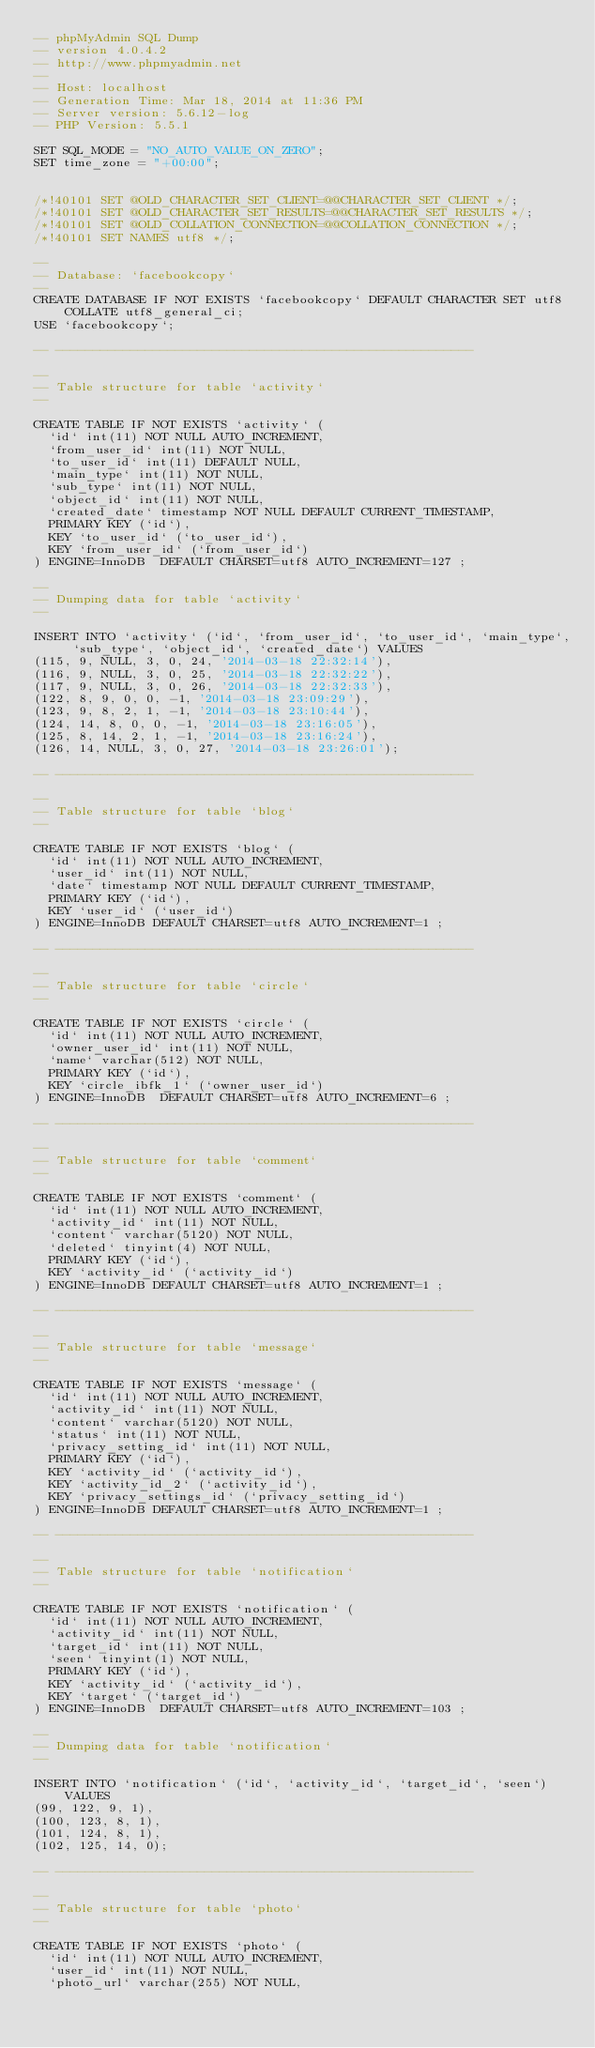Convert code to text. <code><loc_0><loc_0><loc_500><loc_500><_SQL_>-- phpMyAdmin SQL Dump
-- version 4.0.4.2
-- http://www.phpmyadmin.net
--
-- Host: localhost
-- Generation Time: Mar 18, 2014 at 11:36 PM
-- Server version: 5.6.12-log
-- PHP Version: 5.5.1

SET SQL_MODE = "NO_AUTO_VALUE_ON_ZERO";
SET time_zone = "+00:00";


/*!40101 SET @OLD_CHARACTER_SET_CLIENT=@@CHARACTER_SET_CLIENT */;
/*!40101 SET @OLD_CHARACTER_SET_RESULTS=@@CHARACTER_SET_RESULTS */;
/*!40101 SET @OLD_COLLATION_CONNECTION=@@COLLATION_CONNECTION */;
/*!40101 SET NAMES utf8 */;

--
-- Database: `facebookcopy`
--
CREATE DATABASE IF NOT EXISTS `facebookcopy` DEFAULT CHARACTER SET utf8 COLLATE utf8_general_ci;
USE `facebookcopy`;

-- --------------------------------------------------------

--
-- Table structure for table `activity`
--

CREATE TABLE IF NOT EXISTS `activity` (
  `id` int(11) NOT NULL AUTO_INCREMENT,
  `from_user_id` int(11) NOT NULL,
  `to_user_id` int(11) DEFAULT NULL,
  `main_type` int(11) NOT NULL,
  `sub_type` int(11) NOT NULL,
  `object_id` int(11) NOT NULL,
  `created_date` timestamp NOT NULL DEFAULT CURRENT_TIMESTAMP,
  PRIMARY KEY (`id`),
  KEY `to_user_id` (`to_user_id`),
  KEY `from_user_id` (`from_user_id`)
) ENGINE=InnoDB  DEFAULT CHARSET=utf8 AUTO_INCREMENT=127 ;

--
-- Dumping data for table `activity`
--

INSERT INTO `activity` (`id`, `from_user_id`, `to_user_id`, `main_type`, `sub_type`, `object_id`, `created_date`) VALUES
(115, 9, NULL, 3, 0, 24, '2014-03-18 22:32:14'),
(116, 9, NULL, 3, 0, 25, '2014-03-18 22:32:22'),
(117, 9, NULL, 3, 0, 26, '2014-03-18 22:32:33'),
(122, 8, 9, 0, 0, -1, '2014-03-18 23:09:29'),
(123, 9, 8, 2, 1, -1, '2014-03-18 23:10:44'),
(124, 14, 8, 0, 0, -1, '2014-03-18 23:16:05'),
(125, 8, 14, 2, 1, -1, '2014-03-18 23:16:24'),
(126, 14, NULL, 3, 0, 27, '2014-03-18 23:26:01');

-- --------------------------------------------------------

--
-- Table structure for table `blog`
--

CREATE TABLE IF NOT EXISTS `blog` (
  `id` int(11) NOT NULL AUTO_INCREMENT,
  `user_id` int(11) NOT NULL,
  `date` timestamp NOT NULL DEFAULT CURRENT_TIMESTAMP,
  PRIMARY KEY (`id`),
  KEY `user_id` (`user_id`)
) ENGINE=InnoDB DEFAULT CHARSET=utf8 AUTO_INCREMENT=1 ;

-- --------------------------------------------------------

--
-- Table structure for table `circle`
--

CREATE TABLE IF NOT EXISTS `circle` (
  `id` int(11) NOT NULL AUTO_INCREMENT,
  `owner_user_id` int(11) NOT NULL,
  `name` varchar(512) NOT NULL,
  PRIMARY KEY (`id`),
  KEY `circle_ibfk_1` (`owner_user_id`)
) ENGINE=InnoDB  DEFAULT CHARSET=utf8 AUTO_INCREMENT=6 ;

-- --------------------------------------------------------

--
-- Table structure for table `comment`
--

CREATE TABLE IF NOT EXISTS `comment` (
  `id` int(11) NOT NULL AUTO_INCREMENT,
  `activity_id` int(11) NOT NULL,
  `content` varchar(5120) NOT NULL,
  `deleted` tinyint(4) NOT NULL,
  PRIMARY KEY (`id`),
  KEY `activity_id` (`activity_id`)
) ENGINE=InnoDB DEFAULT CHARSET=utf8 AUTO_INCREMENT=1 ;

-- --------------------------------------------------------

--
-- Table structure for table `message`
--

CREATE TABLE IF NOT EXISTS `message` (
  `id` int(11) NOT NULL AUTO_INCREMENT,
  `activity_id` int(11) NOT NULL,
  `content` varchar(5120) NOT NULL,
  `status` int(11) NOT NULL,
  `privacy_setting_id` int(11) NOT NULL,
  PRIMARY KEY (`id`),
  KEY `activity_id` (`activity_id`),
  KEY `activity_id_2` (`activity_id`),
  KEY `privacy_settings_id` (`privacy_setting_id`)
) ENGINE=InnoDB DEFAULT CHARSET=utf8 AUTO_INCREMENT=1 ;

-- --------------------------------------------------------

--
-- Table structure for table `notification`
--

CREATE TABLE IF NOT EXISTS `notification` (
  `id` int(11) NOT NULL AUTO_INCREMENT,
  `activity_id` int(11) NOT NULL,
  `target_id` int(11) NOT NULL,
  `seen` tinyint(1) NOT NULL,
  PRIMARY KEY (`id`),
  KEY `activity_id` (`activity_id`),
  KEY `target` (`target_id`)
) ENGINE=InnoDB  DEFAULT CHARSET=utf8 AUTO_INCREMENT=103 ;

--
-- Dumping data for table `notification`
--

INSERT INTO `notification` (`id`, `activity_id`, `target_id`, `seen`) VALUES
(99, 122, 9, 1),
(100, 123, 8, 1),
(101, 124, 8, 1),
(102, 125, 14, 0);

-- --------------------------------------------------------

--
-- Table structure for table `photo`
--

CREATE TABLE IF NOT EXISTS `photo` (
  `id` int(11) NOT NULL AUTO_INCREMENT,
  `user_id` int(11) NOT NULL,
  `photo_url` varchar(255) NOT NULL,</code> 